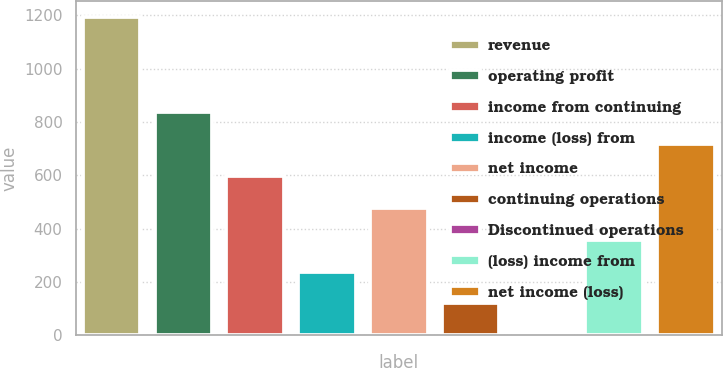Convert chart to OTSL. <chart><loc_0><loc_0><loc_500><loc_500><bar_chart><fcel>revenue<fcel>operating profit<fcel>income from continuing<fcel>income (loss) from<fcel>net income<fcel>continuing operations<fcel>Discontinued operations<fcel>(loss) income from<fcel>net income (loss)<nl><fcel>1194<fcel>835.8<fcel>597.02<fcel>238.85<fcel>477.63<fcel>119.46<fcel>0.07<fcel>358.24<fcel>716.41<nl></chart> 